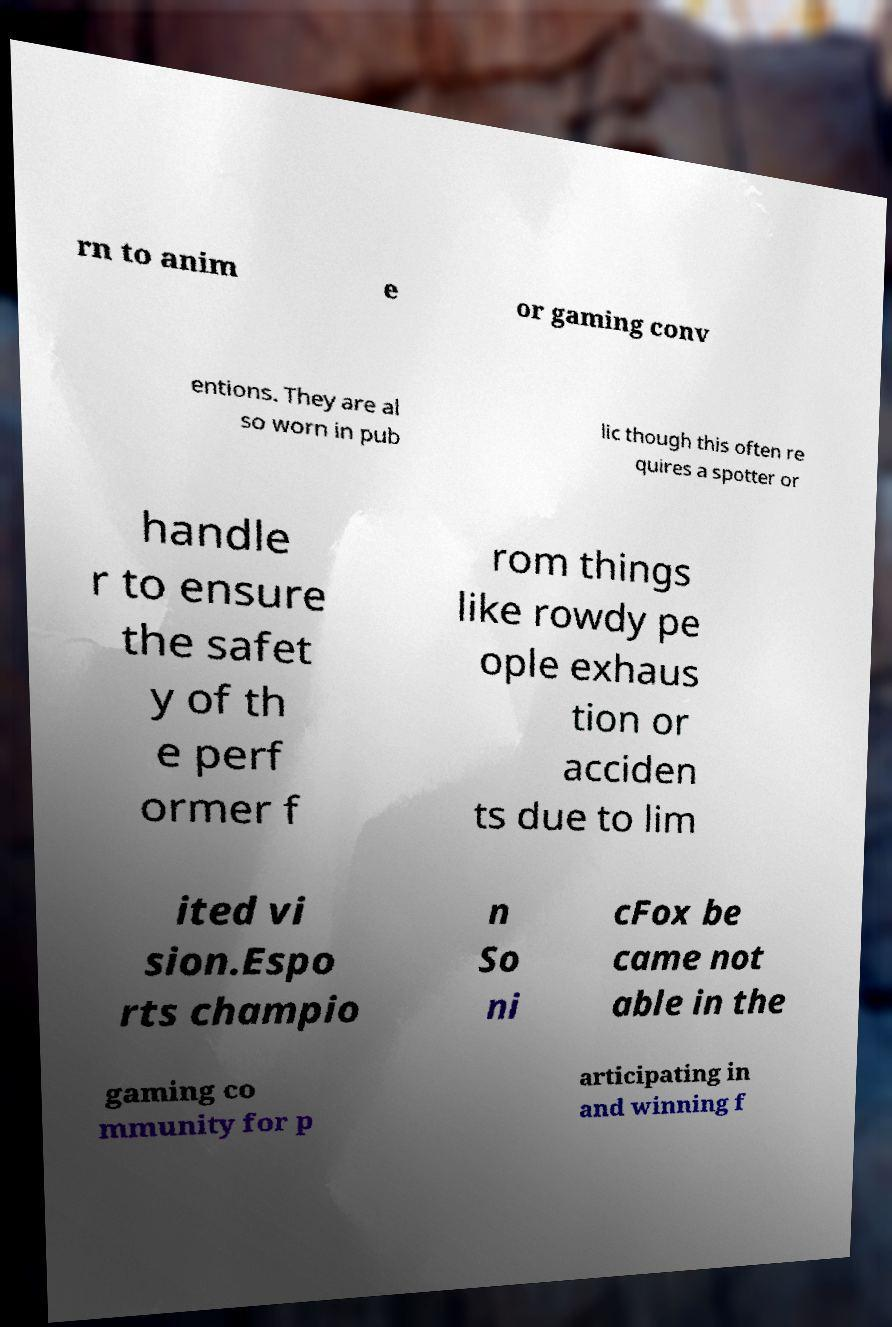Please identify and transcribe the text found in this image. rn to anim e or gaming conv entions. They are al so worn in pub lic though this often re quires a spotter or handle r to ensure the safet y of th e perf ormer f rom things like rowdy pe ople exhaus tion or acciden ts due to lim ited vi sion.Espo rts champio n So ni cFox be came not able in the gaming co mmunity for p articipating in and winning f 